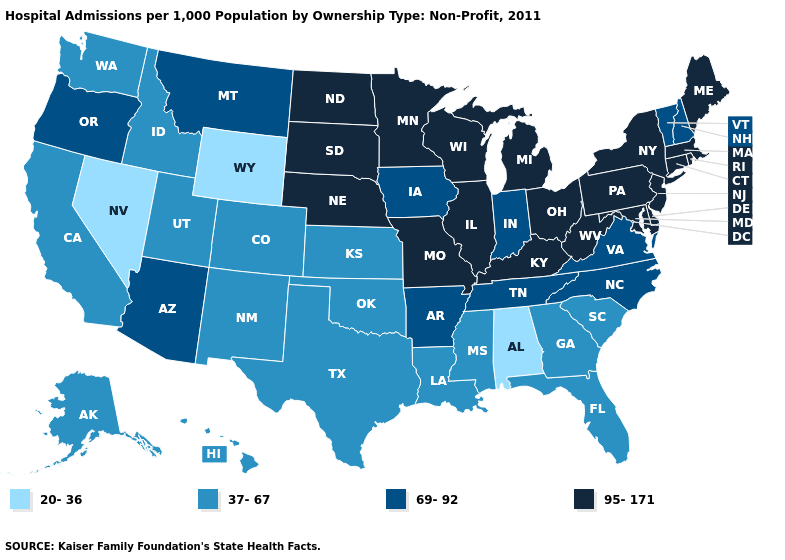What is the lowest value in the USA?
Give a very brief answer. 20-36. What is the value of Massachusetts?
Answer briefly. 95-171. What is the value of New Mexico?
Answer briefly. 37-67. How many symbols are there in the legend?
Quick response, please. 4. What is the value of Louisiana?
Keep it brief. 37-67. Name the states that have a value in the range 20-36?
Give a very brief answer. Alabama, Nevada, Wyoming. Does Utah have the same value as California?
Keep it brief. Yes. Does the map have missing data?
Quick response, please. No. Does the first symbol in the legend represent the smallest category?
Give a very brief answer. Yes. Which states have the highest value in the USA?
Write a very short answer. Connecticut, Delaware, Illinois, Kentucky, Maine, Maryland, Massachusetts, Michigan, Minnesota, Missouri, Nebraska, New Jersey, New York, North Dakota, Ohio, Pennsylvania, Rhode Island, South Dakota, West Virginia, Wisconsin. Which states have the highest value in the USA?
Be succinct. Connecticut, Delaware, Illinois, Kentucky, Maine, Maryland, Massachusetts, Michigan, Minnesota, Missouri, Nebraska, New Jersey, New York, North Dakota, Ohio, Pennsylvania, Rhode Island, South Dakota, West Virginia, Wisconsin. Does the map have missing data?
Write a very short answer. No. Which states hav the highest value in the South?
Quick response, please. Delaware, Kentucky, Maryland, West Virginia. Name the states that have a value in the range 69-92?
Quick response, please. Arizona, Arkansas, Indiana, Iowa, Montana, New Hampshire, North Carolina, Oregon, Tennessee, Vermont, Virginia. Does the first symbol in the legend represent the smallest category?
Concise answer only. Yes. 